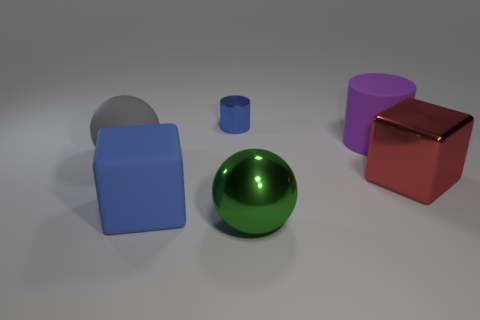Add 4 blue shiny things. How many objects exist? 10 Subtract all spheres. How many objects are left? 4 Subtract all big gray shiny cubes. Subtract all big matte cubes. How many objects are left? 5 Add 3 gray matte balls. How many gray matte balls are left? 4 Add 6 large purple cylinders. How many large purple cylinders exist? 7 Subtract 1 blue blocks. How many objects are left? 5 